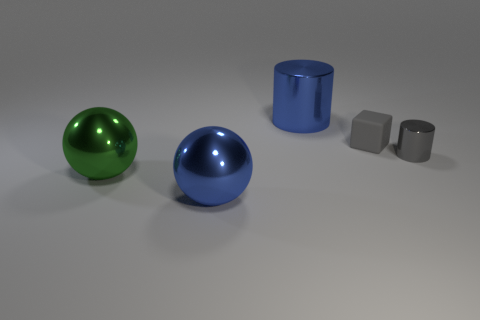There is a large ball that is the same color as the large cylinder; what is its material?
Your answer should be very brief. Metal. There is another metallic object that is the same shape as the small gray metallic thing; what color is it?
Your answer should be compact. Blue. What shape is the big shiny thing in front of the large shiny ball on the left side of the large blue thing in front of the blue cylinder?
Your response must be concise. Sphere. Do the gray metal object and the green object have the same shape?
Offer a terse response. No. There is a tiny thing that is behind the gray object that is on the right side of the small matte cube; what shape is it?
Your answer should be very brief. Cube. Is there a matte block?
Make the answer very short. Yes. There is a large blue shiny thing right of the blue metallic thing that is to the left of the large blue cylinder; how many big blue objects are in front of it?
Make the answer very short. 1. There is a big green thing; does it have the same shape as the large thing that is in front of the green object?
Give a very brief answer. Yes. Is the number of blue cylinders greater than the number of small things?
Give a very brief answer. No. Is there anything else that is the same size as the gray rubber cube?
Offer a very short reply. Yes. 